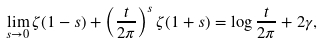<formula> <loc_0><loc_0><loc_500><loc_500>\lim _ { s \rightarrow 0 } \zeta ( 1 - s ) + \left ( \frac { t } { 2 \pi } \right ) ^ { s } \zeta ( 1 + s ) = \log \frac { t } { 2 \pi } + 2 \gamma ,</formula> 